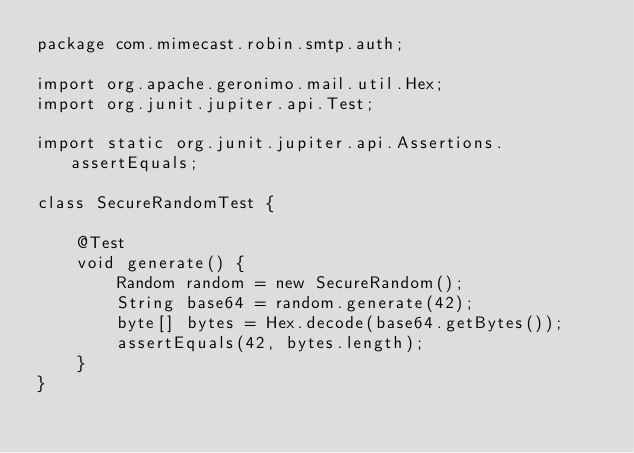<code> <loc_0><loc_0><loc_500><loc_500><_Java_>package com.mimecast.robin.smtp.auth;

import org.apache.geronimo.mail.util.Hex;
import org.junit.jupiter.api.Test;

import static org.junit.jupiter.api.Assertions.assertEquals;

class SecureRandomTest {

    @Test
    void generate() {
        Random random = new SecureRandom();
        String base64 = random.generate(42);
        byte[] bytes = Hex.decode(base64.getBytes());
        assertEquals(42, bytes.length);
    }
}
</code> 